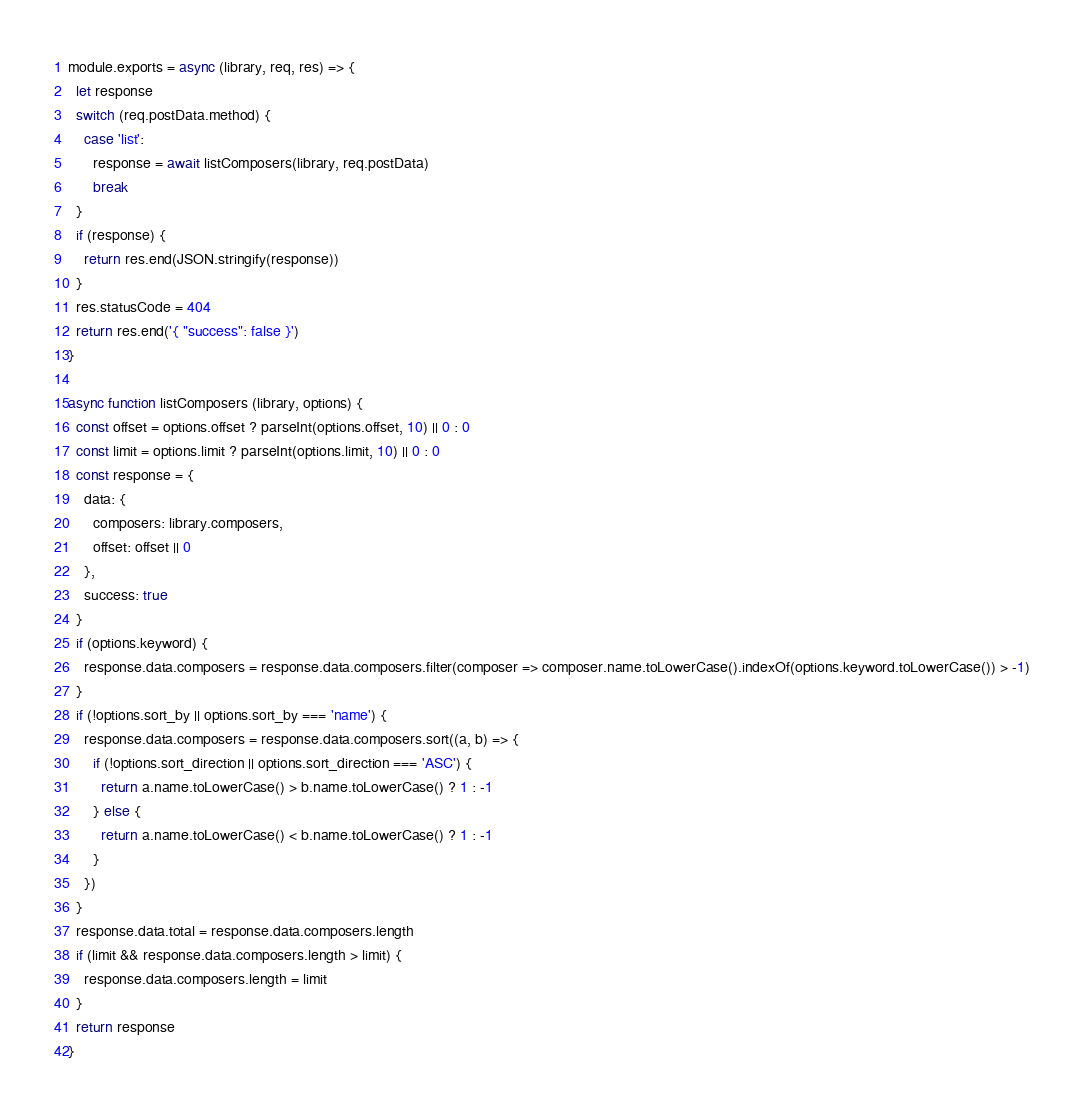<code> <loc_0><loc_0><loc_500><loc_500><_JavaScript_>module.exports = async (library, req, res) => {
  let response
  switch (req.postData.method) {
    case 'list':
      response = await listComposers(library, req.postData)
      break
  }
  if (response) {
    return res.end(JSON.stringify(response))
  }
  res.statusCode = 404
  return res.end('{ "success": false }')
}

async function listComposers (library, options) {
  const offset = options.offset ? parseInt(options.offset, 10) || 0 : 0
  const limit = options.limit ? parseInt(options.limit, 10) || 0 : 0
  const response = {
    data: {
      composers: library.composers,
      offset: offset || 0
    },
    success: true
  }
  if (options.keyword) {
    response.data.composers = response.data.composers.filter(composer => composer.name.toLowerCase().indexOf(options.keyword.toLowerCase()) > -1)
  }
  if (!options.sort_by || options.sort_by === 'name') {
    response.data.composers = response.data.composers.sort((a, b) => {
      if (!options.sort_direction || options.sort_direction === 'ASC') {
        return a.name.toLowerCase() > b.name.toLowerCase() ? 1 : -1
      } else {
        return a.name.toLowerCase() < b.name.toLowerCase() ? 1 : -1
      }
    })
  }
  response.data.total = response.data.composers.length
  if (limit && response.data.composers.length > limit) {
    response.data.composers.length = limit
  }
  return response
}
</code> 